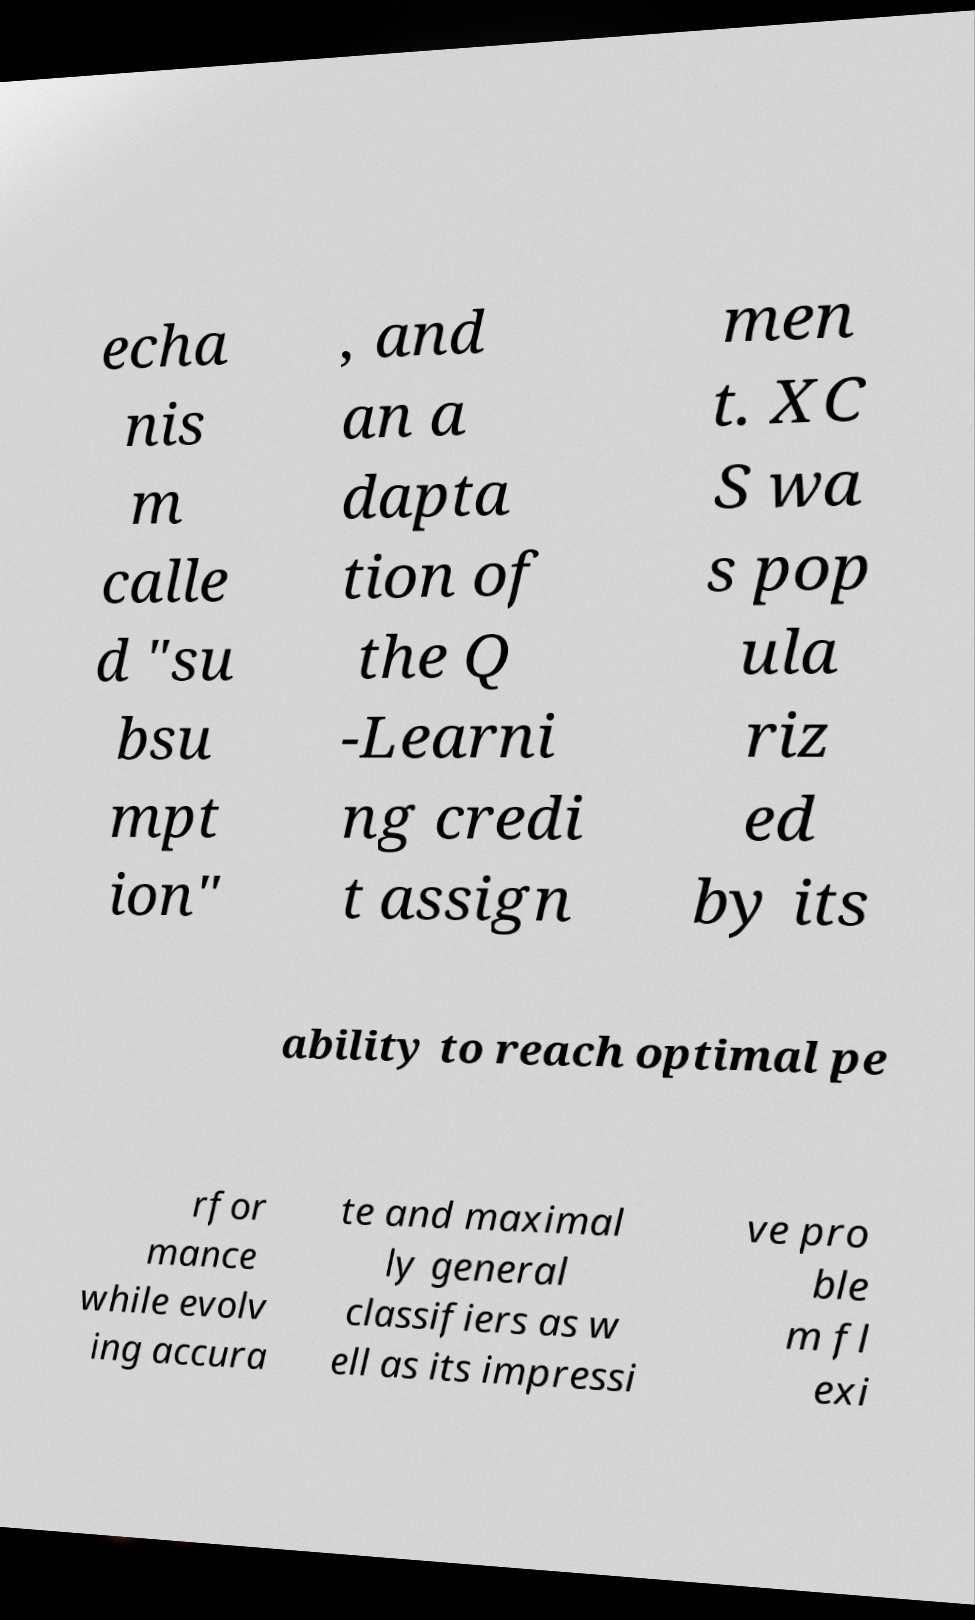Can you accurately transcribe the text from the provided image for me? echa nis m calle d "su bsu mpt ion" , and an a dapta tion of the Q -Learni ng credi t assign men t. XC S wa s pop ula riz ed by its ability to reach optimal pe rfor mance while evolv ing accura te and maximal ly general classifiers as w ell as its impressi ve pro ble m fl exi 